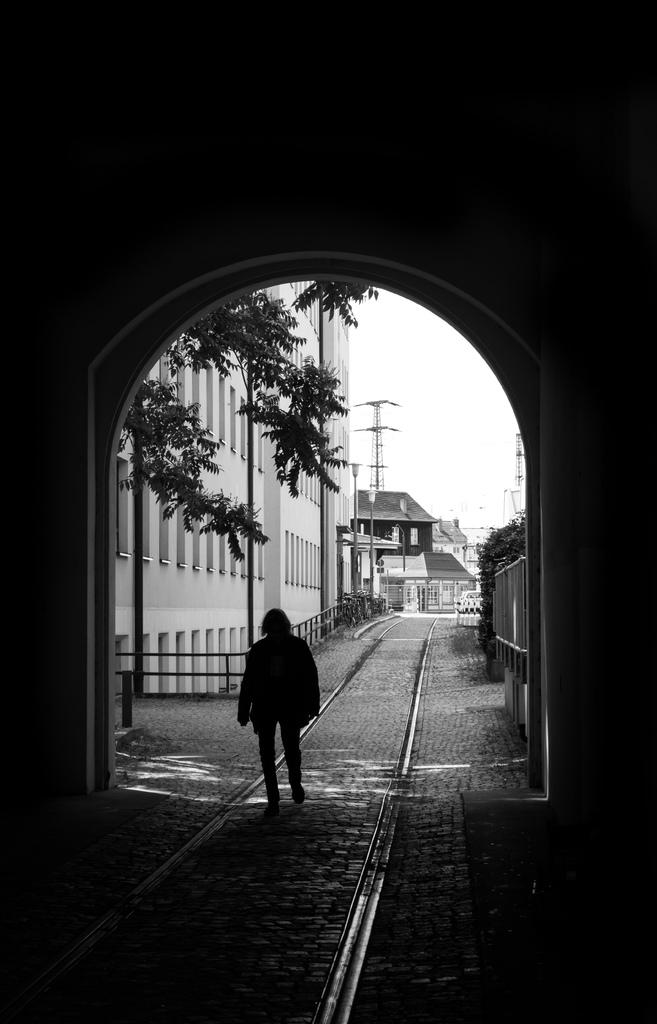What is the main subject in the foreground of the image? There is a person in the foreground of the image. Where is the person located? The person is on the road. What can be seen in the background of the image? There are buildings, trees, towers, light poles, and the sky visible in the background of the image. What type of paper is the person holding in the image? There is no paper visible in the image; the person is on the road and there are no objects in their hands. 